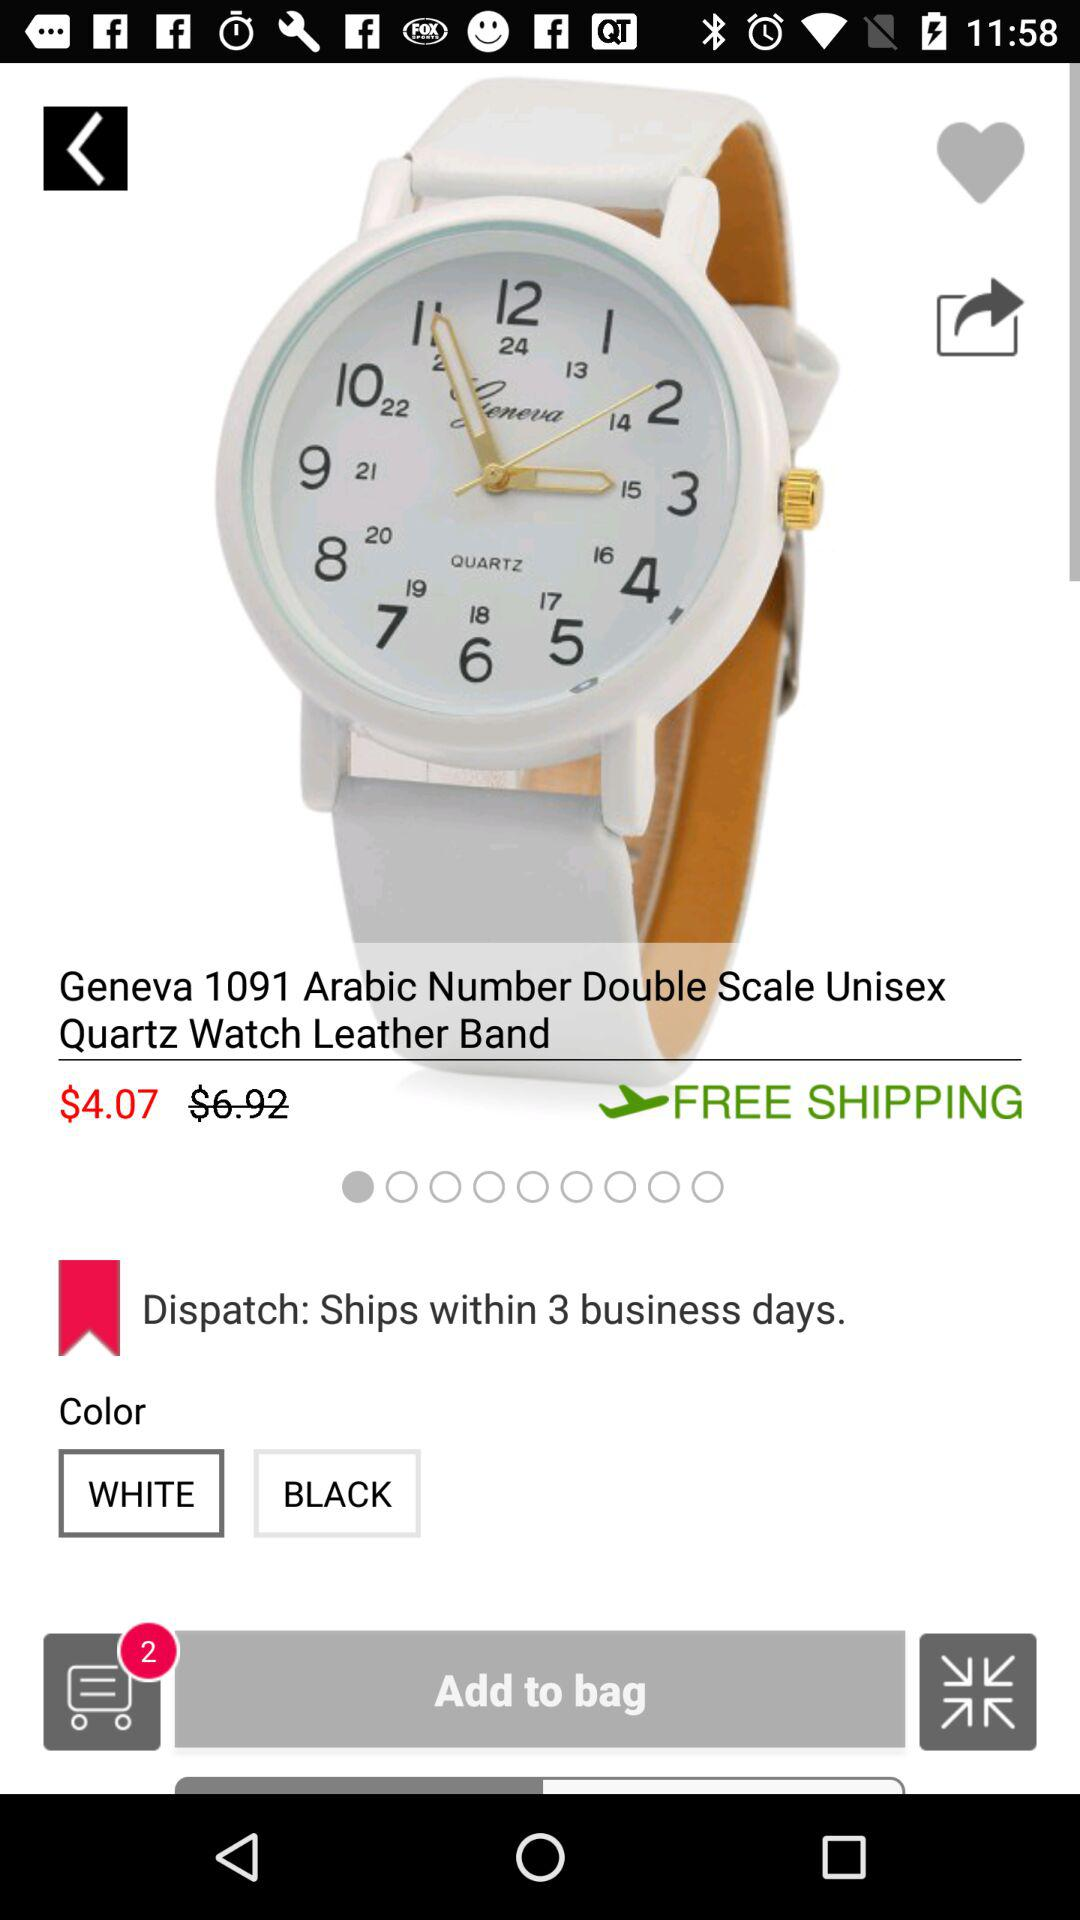When does the discounted price expire?
When the provided information is insufficient, respond with <no answer>. <no answer> 